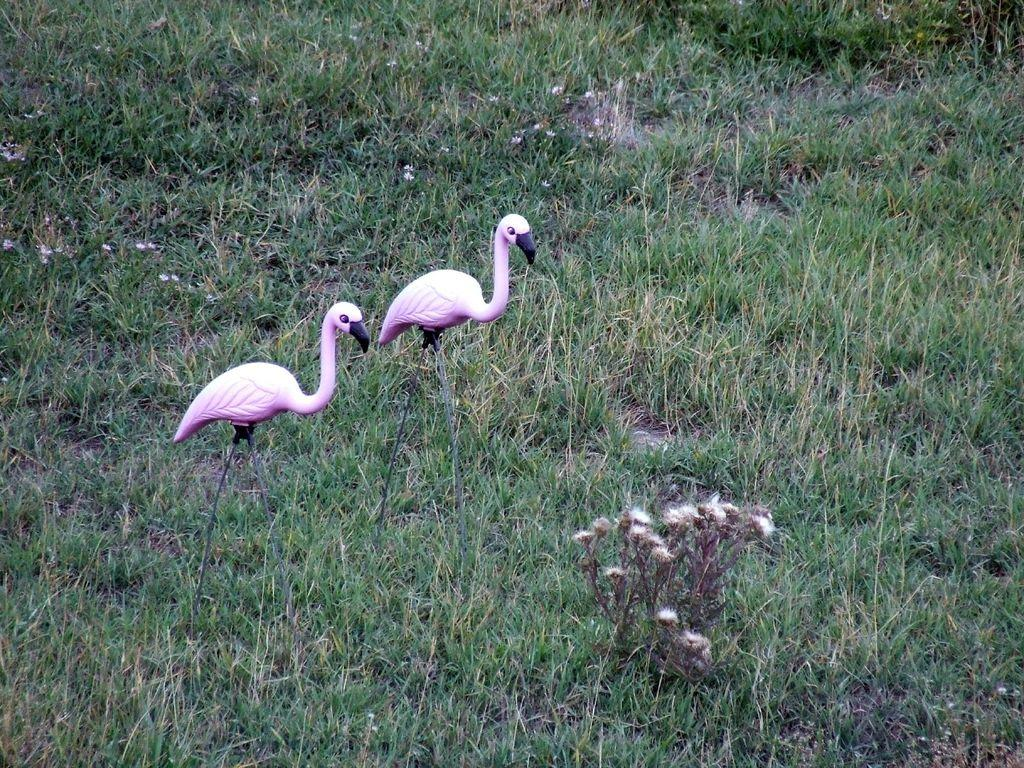What type of animals can be seen in the image? There are birds in the image. What other living organisms are present in the image? There are plants, grass, and flowers in the image. Can you describe the natural environment depicted in the image? The image features birds, plants, grass, and flowers, which suggests a natural setting. What type of card is being used by the pigs in the image? There are no pigs or cards present in the image. 